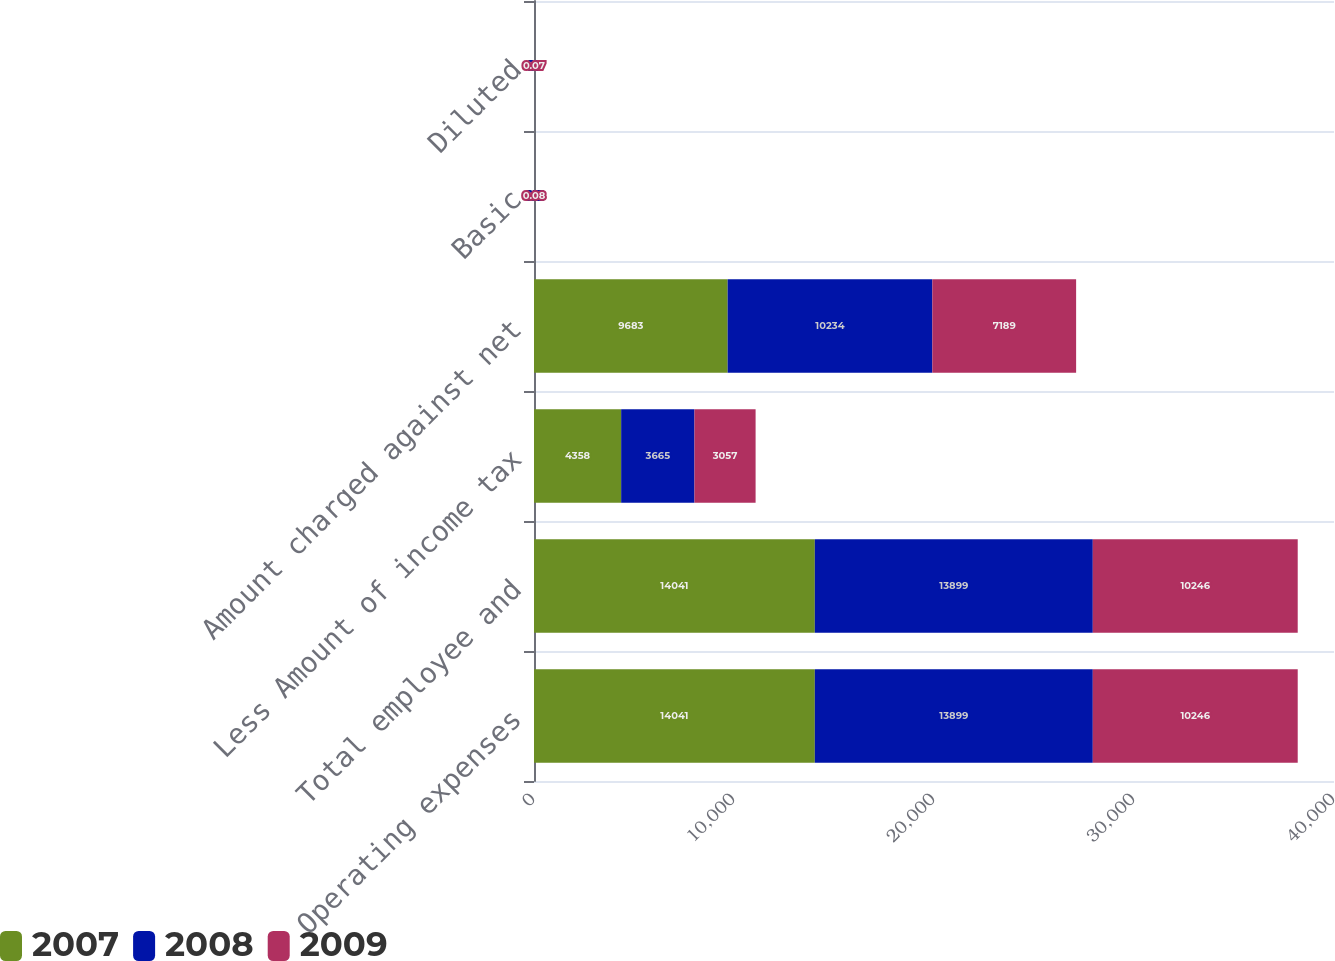<chart> <loc_0><loc_0><loc_500><loc_500><stacked_bar_chart><ecel><fcel>Operating expenses<fcel>Total employee and<fcel>Less Amount of income tax<fcel>Amount charged against net<fcel>Basic<fcel>Diluted<nl><fcel>2007<fcel>14041<fcel>14041<fcel>4358<fcel>9683<fcel>0.11<fcel>0.1<nl><fcel>2008<fcel>13899<fcel>13899<fcel>3665<fcel>10234<fcel>0.11<fcel>0.1<nl><fcel>2009<fcel>10246<fcel>10246<fcel>3057<fcel>7189<fcel>0.08<fcel>0.07<nl></chart> 